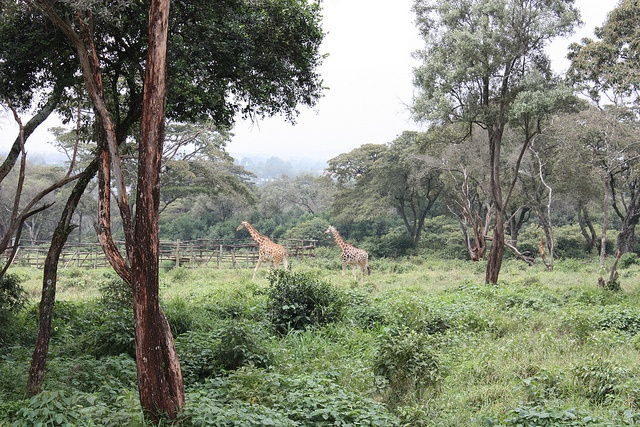Describe the objects in this image and their specific colors. I can see giraffe in black, darkgray, tan, and gray tones and giraffe in black, tan, and darkgray tones in this image. 